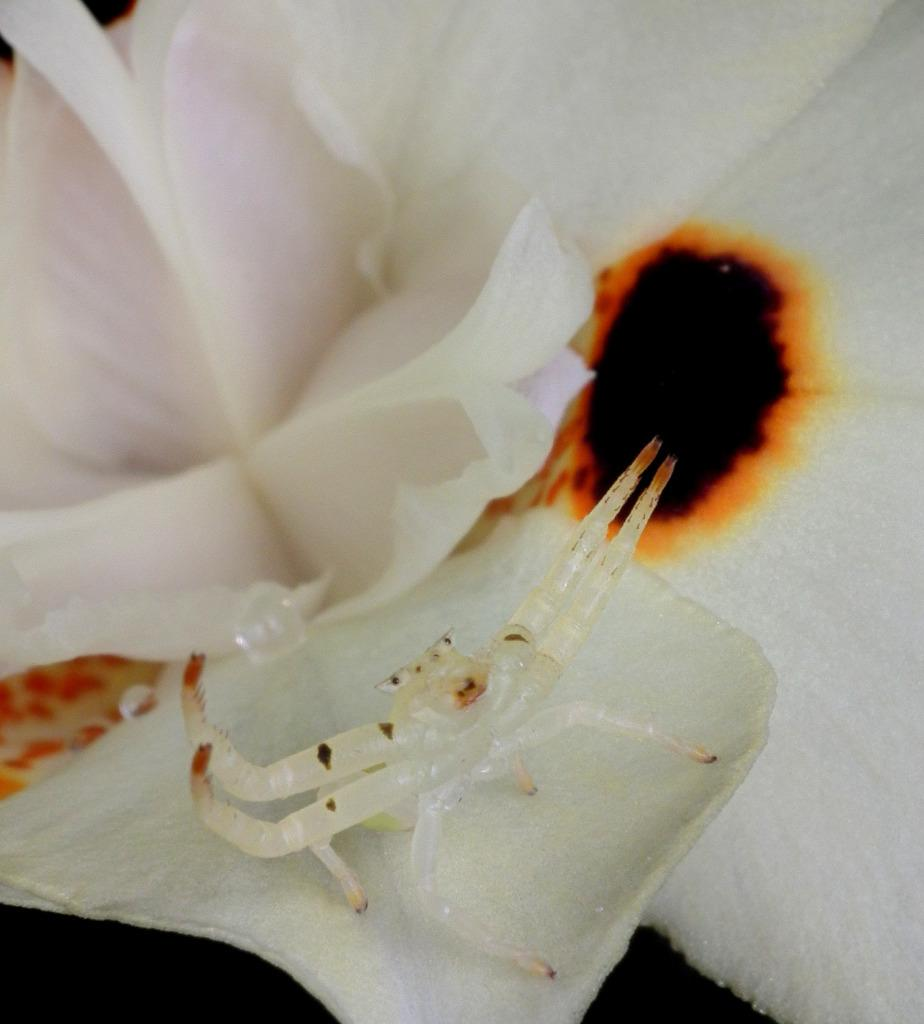What type of living organism can be seen in the image? There is an insect in the image. What type of plants are in the image? There are flowers in the image. What is the color of the background in the image? The background of the image is dark. What type of machine is visible in the image? There is no machine present in the image; it features an insect and flowers against a dark background. 